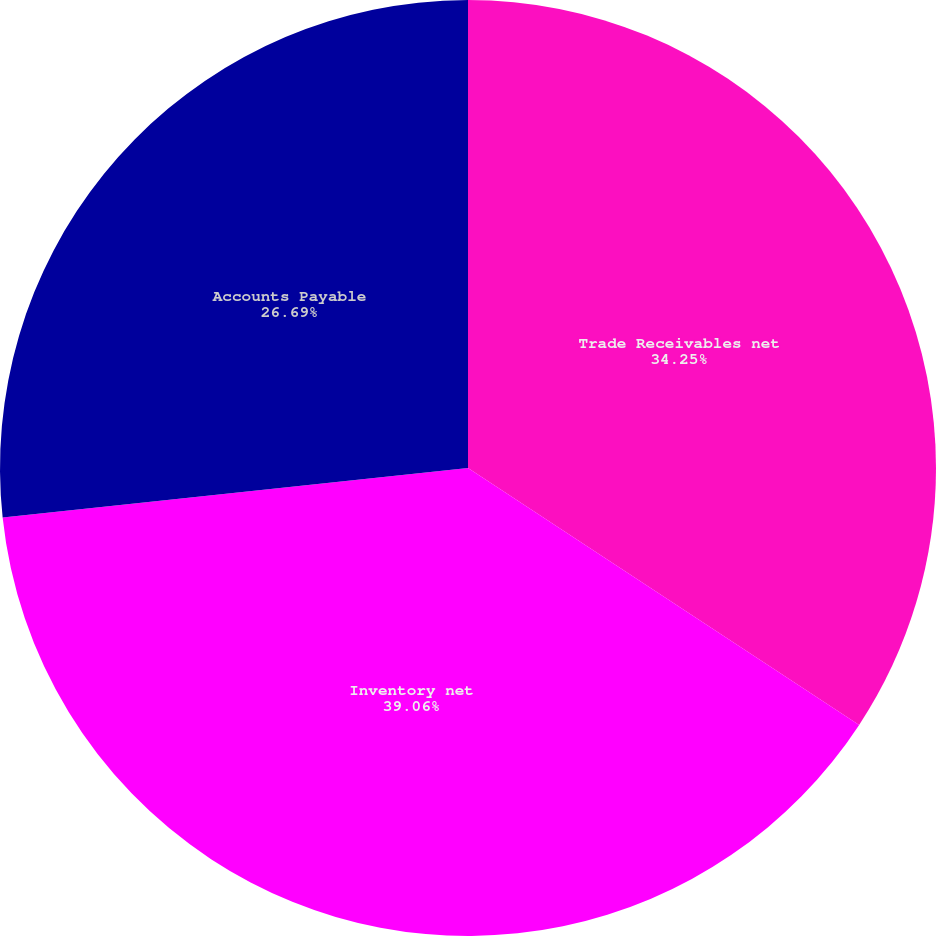Convert chart. <chart><loc_0><loc_0><loc_500><loc_500><pie_chart><fcel>Trade Receivables net<fcel>Inventory net<fcel>Accounts Payable<nl><fcel>34.25%<fcel>39.06%<fcel>26.69%<nl></chart> 